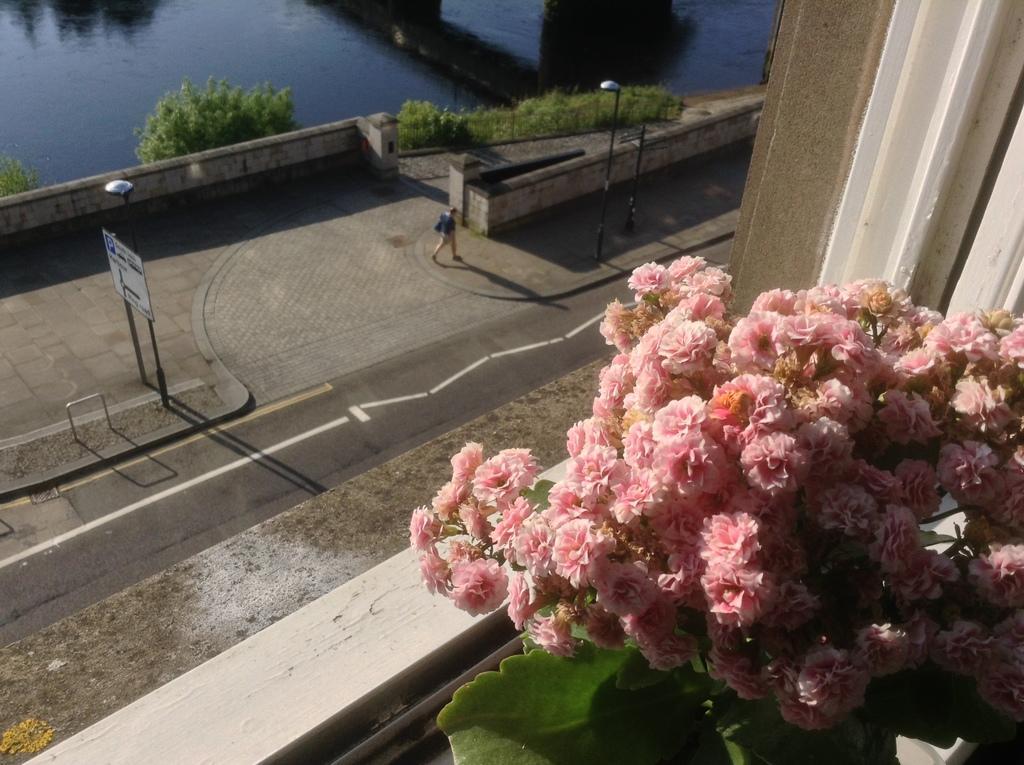In one or two sentences, can you explain what this image depicts? In this image there is a river truncated towards the top of the image, there are plants, there is a plant truncated towards the left of the image, there is a person walking, there are poles, there are lights, there is board, there is text on the board, there are flowers truncated towards the right of the image, there is leaves truncated towards the bottom of the image, there is wall truncated towards the top of the image, there is wall truncated towards the bottom of the image. 